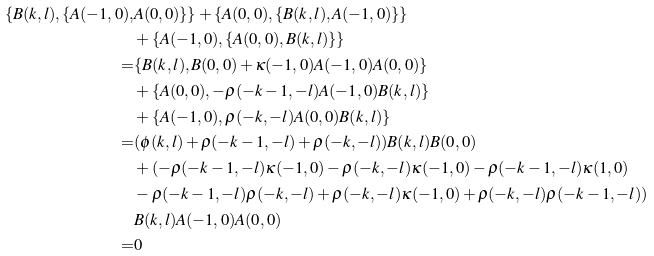Convert formula to latex. <formula><loc_0><loc_0><loc_500><loc_500>\{ B ( k , l ) , \{ A ( - 1 , 0 ) , & A ( 0 , 0 ) \} \} + \{ A ( 0 , 0 ) , \{ B ( k , l ) , A ( - 1 , 0 ) \} \} \\ & + \{ A ( - 1 , 0 ) , \{ A ( 0 , 0 ) , B ( k , l ) \} \} \\ = & \{ B ( k , l ) , B ( 0 , 0 ) + \kappa ( - 1 , 0 ) A ( - 1 , 0 ) A ( 0 , 0 ) \} \\ & + \{ A ( 0 , 0 ) , - \rho ( - k - 1 , - l ) A ( - 1 , 0 ) B ( k , l ) \} \\ & + \{ A ( - 1 , 0 ) , \rho ( - k , - l ) A ( 0 , 0 ) B ( k , l ) \} \\ = & ( \phi ( k , l ) + \rho ( - k - 1 , - l ) + \rho ( - k , - l ) ) B ( k , l ) B ( 0 , 0 ) \\ & + ( - \rho ( - k - 1 , - l ) \kappa ( - 1 , 0 ) - \rho ( - k , - l ) \kappa ( - 1 , 0 ) - \rho ( - k - 1 , - l ) \kappa ( 1 , 0 ) \\ & - \rho ( - k - 1 , - l ) \rho ( - k , - l ) + \rho ( - k , - l ) \kappa ( - 1 , 0 ) + \rho ( - k , - l ) \rho ( - k - 1 , - l ) ) \\ & B ( k , l ) A ( - 1 , 0 ) A ( 0 , 0 ) \\ = & 0 \\</formula> 